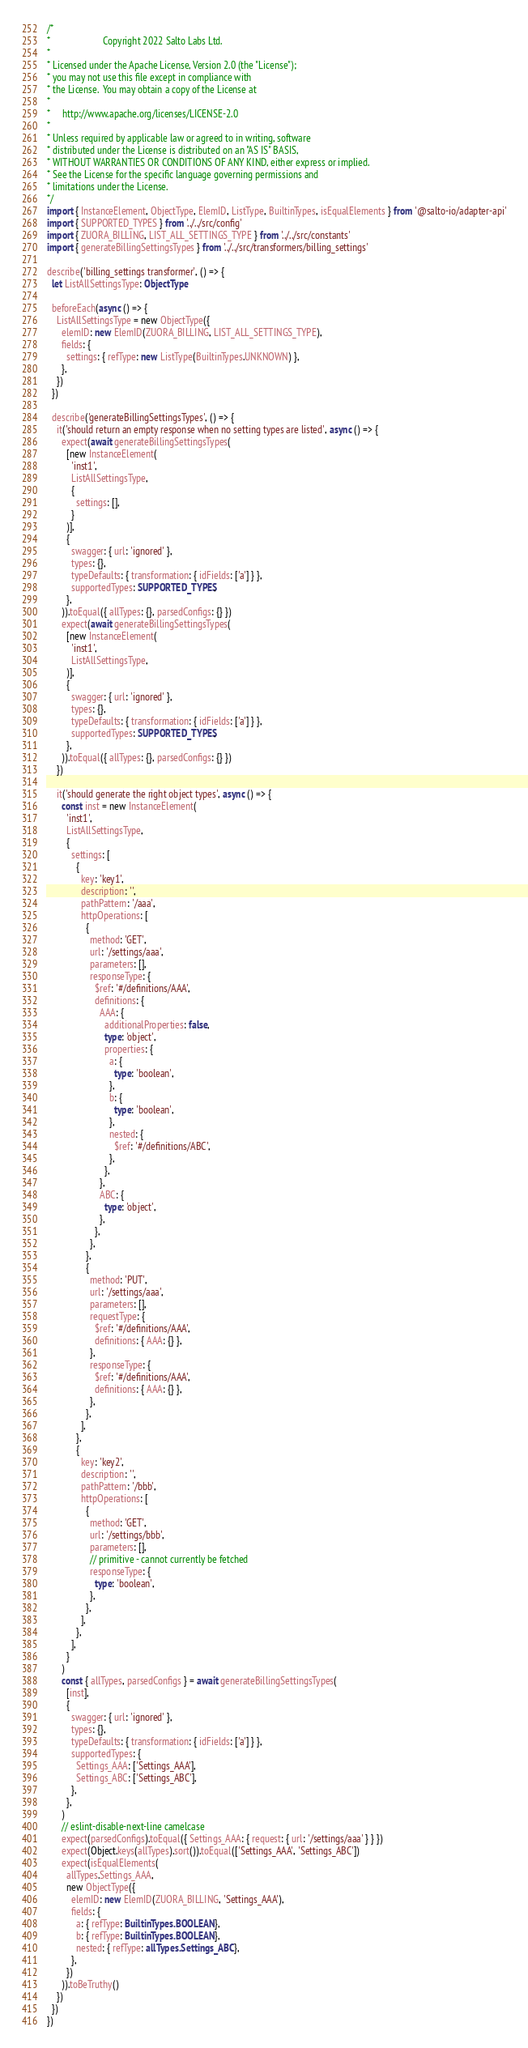Convert code to text. <code><loc_0><loc_0><loc_500><loc_500><_TypeScript_>/*
*                      Copyright 2022 Salto Labs Ltd.
*
* Licensed under the Apache License, Version 2.0 (the "License");
* you may not use this file except in compliance with
* the License.  You may obtain a copy of the License at
*
*     http://www.apache.org/licenses/LICENSE-2.0
*
* Unless required by applicable law or agreed to in writing, software
* distributed under the License is distributed on an "AS IS" BASIS,
* WITHOUT WARRANTIES OR CONDITIONS OF ANY KIND, either express or implied.
* See the License for the specific language governing permissions and
* limitations under the License.
*/
import { InstanceElement, ObjectType, ElemID, ListType, BuiltinTypes, isEqualElements } from '@salto-io/adapter-api'
import { SUPPORTED_TYPES } from '../../src/config'
import { ZUORA_BILLING, LIST_ALL_SETTINGS_TYPE } from '../../src/constants'
import { generateBillingSettingsTypes } from '../../src/transformers/billing_settings'

describe('billing_settings transformer', () => {
  let ListAllSettingsType: ObjectType

  beforeEach(async () => {
    ListAllSettingsType = new ObjectType({
      elemID: new ElemID(ZUORA_BILLING, LIST_ALL_SETTINGS_TYPE),
      fields: {
        settings: { refType: new ListType(BuiltinTypes.UNKNOWN) },
      },
    })
  })

  describe('generateBillingSettingsTypes', () => {
    it('should return an empty response when no setting types are listed', async () => {
      expect(await generateBillingSettingsTypes(
        [new InstanceElement(
          'inst1',
          ListAllSettingsType,
          {
            settings: [],
          }
        )],
        {
          swagger: { url: 'ignored' },
          types: {},
          typeDefaults: { transformation: { idFields: ['a'] } },
          supportedTypes: SUPPORTED_TYPES,
        },
      )).toEqual({ allTypes: {}, parsedConfigs: {} })
      expect(await generateBillingSettingsTypes(
        [new InstanceElement(
          'inst1',
          ListAllSettingsType,
        )],
        {
          swagger: { url: 'ignored' },
          types: {},
          typeDefaults: { transformation: { idFields: ['a'] } },
          supportedTypes: SUPPORTED_TYPES,
        },
      )).toEqual({ allTypes: {}, parsedConfigs: {} })
    })

    it('should generate the right object types', async () => {
      const inst = new InstanceElement(
        'inst1',
        ListAllSettingsType,
        {
          settings: [
            {
              key: 'key1',
              description: '',
              pathPattern: '/aaa',
              httpOperations: [
                {
                  method: 'GET',
                  url: '/settings/aaa',
                  parameters: [],
                  responseType: {
                    $ref: '#/definitions/AAA',
                    definitions: {
                      AAA: {
                        additionalProperties: false,
                        type: 'object',
                        properties: {
                          a: {
                            type: 'boolean',
                          },
                          b: {
                            type: 'boolean',
                          },
                          nested: {
                            $ref: '#/definitions/ABC',
                          },
                        },
                      },
                      ABC: {
                        type: 'object',
                      },
                    },
                  },
                },
                {
                  method: 'PUT',
                  url: '/settings/aaa',
                  parameters: [],
                  requestType: {
                    $ref: '#/definitions/AAA',
                    definitions: { AAA: {} },
                  },
                  responseType: {
                    $ref: '#/definitions/AAA',
                    definitions: { AAA: {} },
                  },
                },
              ],
            },
            {
              key: 'key2',
              description: '',
              pathPattern: '/bbb',
              httpOperations: [
                {
                  method: 'GET',
                  url: '/settings/bbb',
                  parameters: [],
                  // primitive - cannot currently be fetched
                  responseType: {
                    type: 'boolean',
                  },
                },
              ],
            },
          ],
        }
      )
      const { allTypes, parsedConfigs } = await generateBillingSettingsTypes(
        [inst],
        {
          swagger: { url: 'ignored' },
          types: {},
          typeDefaults: { transformation: { idFields: ['a'] } },
          supportedTypes: {
            Settings_AAA: ['Settings_AAA'],
            Settings_ABC: ['Settings_ABC'],
          },
        },
      )
      // eslint-disable-next-line camelcase
      expect(parsedConfigs).toEqual({ Settings_AAA: { request: { url: '/settings/aaa' } } })
      expect(Object.keys(allTypes).sort()).toEqual(['Settings_AAA', 'Settings_ABC'])
      expect(isEqualElements(
        allTypes.Settings_AAA,
        new ObjectType({
          elemID: new ElemID(ZUORA_BILLING, 'Settings_AAA'),
          fields: {
            a: { refType: BuiltinTypes.BOOLEAN },
            b: { refType: BuiltinTypes.BOOLEAN },
            nested: { refType: allTypes.Settings_ABC },
          },
        })
      )).toBeTruthy()
    })
  })
})
</code> 